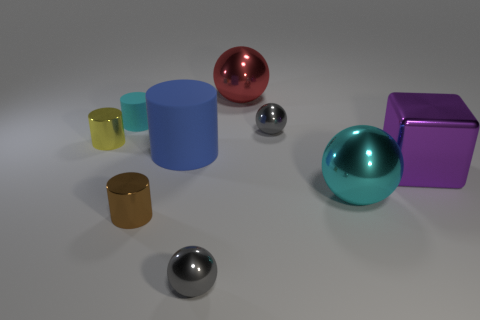What number of other things are there of the same size as the yellow metallic thing?
Ensure brevity in your answer.  4. There is a thing that is both right of the brown cylinder and in front of the cyan sphere; what is its size?
Offer a terse response. Small. There is a small shiny thing in front of the brown cylinder; does it have the same color as the rubber object in front of the small cyan rubber object?
Offer a very short reply. No. How many tiny cyan matte cylinders are in front of the small brown metal cylinder?
Ensure brevity in your answer.  0. There is a small gray metal thing on the right side of the shiny sphere that is in front of the big cyan shiny sphere; is there a tiny thing behind it?
Keep it short and to the point. Yes. What number of blue rubber objects have the same size as the blue cylinder?
Give a very brief answer. 0. There is a gray ball that is behind the metallic cylinder left of the tiny cyan thing; what is it made of?
Your response must be concise. Metal. The small gray metal object that is to the left of the small gray shiny sphere that is behind the gray ball on the left side of the large red metal object is what shape?
Your answer should be compact. Sphere. There is a large matte thing behind the small brown shiny cylinder; does it have the same shape as the big metal object that is behind the tiny cyan cylinder?
Provide a succinct answer. No. How many other things are there of the same material as the red object?
Your response must be concise. 6. 